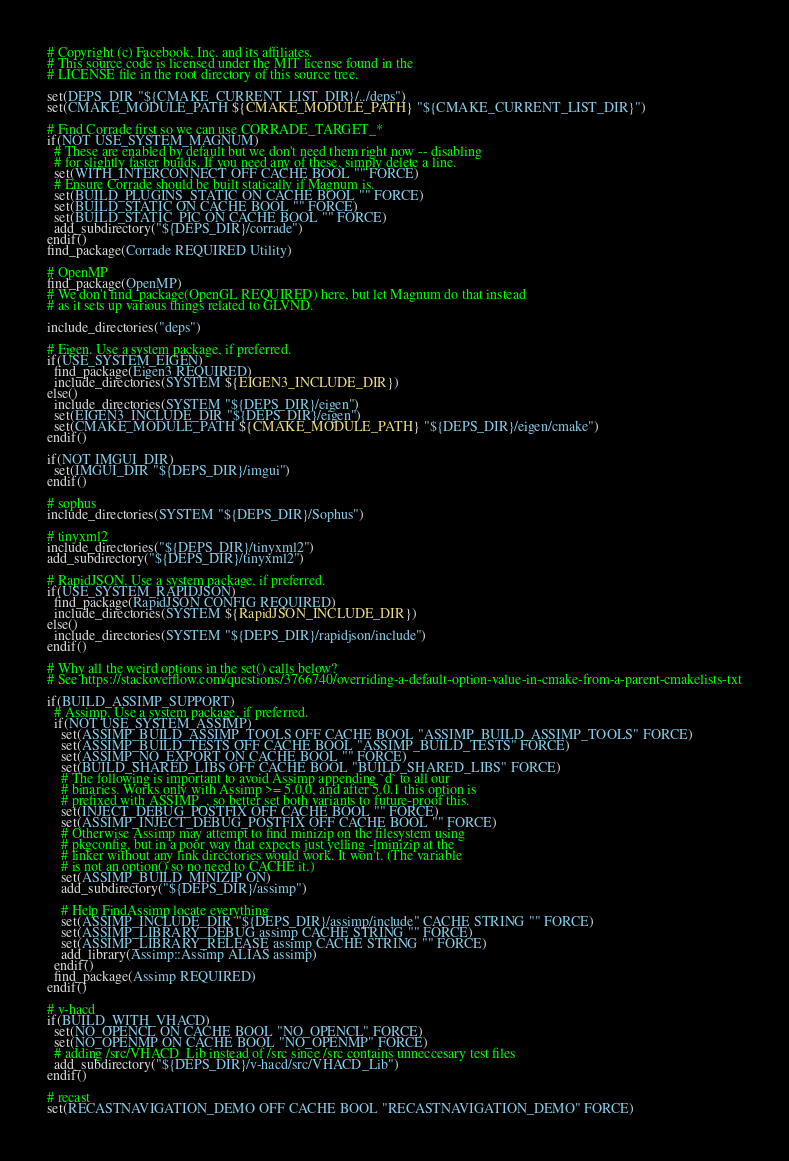<code> <loc_0><loc_0><loc_500><loc_500><_CMake_># Copyright (c) Facebook, Inc. and its affiliates.
# This source code is licensed under the MIT license found in the
# LICENSE file in the root directory of this source tree.

set(DEPS_DIR "${CMAKE_CURRENT_LIST_DIR}/../deps")
set(CMAKE_MODULE_PATH ${CMAKE_MODULE_PATH} "${CMAKE_CURRENT_LIST_DIR}")

# Find Corrade first so we can use CORRADE_TARGET_*
if(NOT USE_SYSTEM_MAGNUM)
  # These are enabled by default but we don't need them right now -- disabling
  # for slightly faster builds. If you need any of these, simply delete a line.
  set(WITH_INTERCONNECT OFF CACHE BOOL "" FORCE)
  # Ensure Corrade should be built statically if Magnum is.
  set(BUILD_PLUGINS_STATIC ON CACHE BOOL "" FORCE)
  set(BUILD_STATIC ON CACHE BOOL "" FORCE)
  set(BUILD_STATIC_PIC ON CACHE BOOL "" FORCE)
  add_subdirectory("${DEPS_DIR}/corrade")
endif()
find_package(Corrade REQUIRED Utility)

# OpenMP
find_package(OpenMP)
# We don't find_package(OpenGL REQUIRED) here, but let Magnum do that instead
# as it sets up various things related to GLVND.

include_directories("deps")

# Eigen. Use a system package, if preferred.
if(USE_SYSTEM_EIGEN)
  find_package(Eigen3 REQUIRED)
  include_directories(SYSTEM ${EIGEN3_INCLUDE_DIR})
else()
  include_directories(SYSTEM "${DEPS_DIR}/eigen")
  set(EIGEN3_INCLUDE_DIR "${DEPS_DIR}/eigen")
  set(CMAKE_MODULE_PATH ${CMAKE_MODULE_PATH} "${DEPS_DIR}/eigen/cmake")
endif()

if(NOT IMGUI_DIR)
  set(IMGUI_DIR "${DEPS_DIR}/imgui")
endif()

# sophus
include_directories(SYSTEM "${DEPS_DIR}/Sophus")

# tinyxml2
include_directories("${DEPS_DIR}/tinyxml2")
add_subdirectory("${DEPS_DIR}/tinyxml2")

# RapidJSON. Use a system package, if preferred.
if(USE_SYSTEM_RAPIDJSON)
  find_package(RapidJSON CONFIG REQUIRED)
  include_directories(SYSTEM ${RapidJSON_INCLUDE_DIR})
else()
  include_directories(SYSTEM "${DEPS_DIR}/rapidjson/include")
endif()

# Why all the weird options in the set() calls below?
# See https://stackoverflow.com/questions/3766740/overriding-a-default-option-value-in-cmake-from-a-parent-cmakelists-txt

if(BUILD_ASSIMP_SUPPORT)
  # Assimp. Use a system package, if preferred.
  if(NOT USE_SYSTEM_ASSIMP)
    set(ASSIMP_BUILD_ASSIMP_TOOLS OFF CACHE BOOL "ASSIMP_BUILD_ASSIMP_TOOLS" FORCE)
    set(ASSIMP_BUILD_TESTS OFF CACHE BOOL "ASSIMP_BUILD_TESTS" FORCE)
    set(ASSIMP_NO_EXPORT ON CACHE BOOL "" FORCE)
    set(BUILD_SHARED_LIBS OFF CACHE BOOL "BUILD_SHARED_LIBS" FORCE)
    # The following is important to avoid Assimp appending `d` to all our
    # binaries. Works only with Assimp >= 5.0.0, and after 5.0.1 this option is
    # prefixed with ASSIMP_, so better set both variants to future-proof this.
    set(INJECT_DEBUG_POSTFIX OFF CACHE BOOL "" FORCE)
    set(ASSIMP_INJECT_DEBUG_POSTFIX OFF CACHE BOOL "" FORCE)
    # Otherwise Assimp may attempt to find minizip on the filesystem using
    # pkgconfig, but in a poor way that expects just yelling -lminizip at the
    # linker without any link directories would work. It won't. (The variable
    # is not an option() so no need to CACHE it.)
    set(ASSIMP_BUILD_MINIZIP ON)
    add_subdirectory("${DEPS_DIR}/assimp")

    # Help FindAssimp locate everything
    set(ASSIMP_INCLUDE_DIR "${DEPS_DIR}/assimp/include" CACHE STRING "" FORCE)
    set(ASSIMP_LIBRARY_DEBUG assimp CACHE STRING "" FORCE)
    set(ASSIMP_LIBRARY_RELEASE assimp CACHE STRING "" FORCE)
    add_library(Assimp::Assimp ALIAS assimp)
  endif()
  find_package(Assimp REQUIRED)
endif()

# v-hacd
if(BUILD_WITH_VHACD)
  set(NO_OPENCL ON CACHE BOOL "NO_OPENCL" FORCE)
  set(NO_OPENMP ON CACHE BOOL "NO_OPENMP" FORCE)
  # adding /src/VHACD_Lib instead of /src since /src contains unneccesary test files
  add_subdirectory("${DEPS_DIR}/v-hacd/src/VHACD_Lib")
endif()

# recast
set(RECASTNAVIGATION_DEMO OFF CACHE BOOL "RECASTNAVIGATION_DEMO" FORCE)</code> 